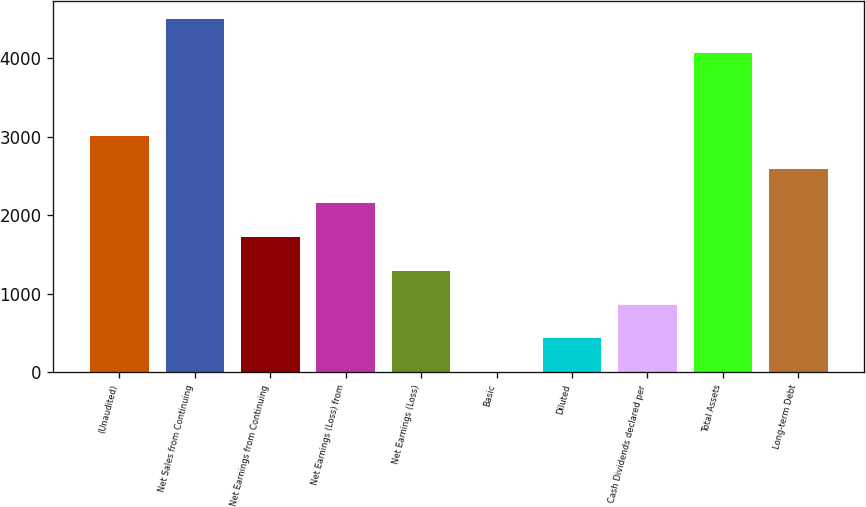Convert chart. <chart><loc_0><loc_0><loc_500><loc_500><bar_chart><fcel>(Unaudited)<fcel>Net Sales from Continuing<fcel>Net Earnings from Continuing<fcel>Net Earnings (Loss) from<fcel>Net Earnings (Loss)<fcel>Basic<fcel>Diluted<fcel>Cash Dividends declared per<fcel>Total Assets<fcel>Long-term Debt<nl><fcel>3014.27<fcel>4503.07<fcel>1722.56<fcel>2153.13<fcel>1291.99<fcel>0.28<fcel>430.85<fcel>861.42<fcel>4072.5<fcel>2583.7<nl></chart> 